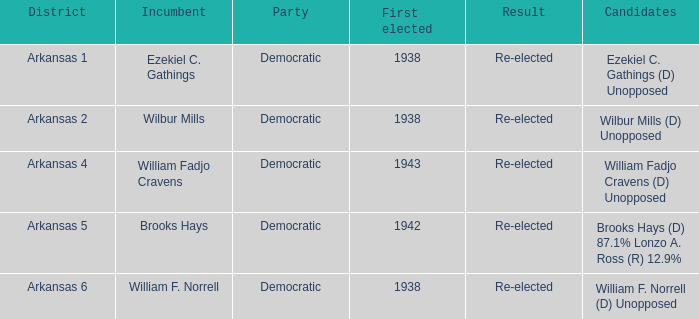What is the earliest years any of the incumbents were first elected?  1938.0. 